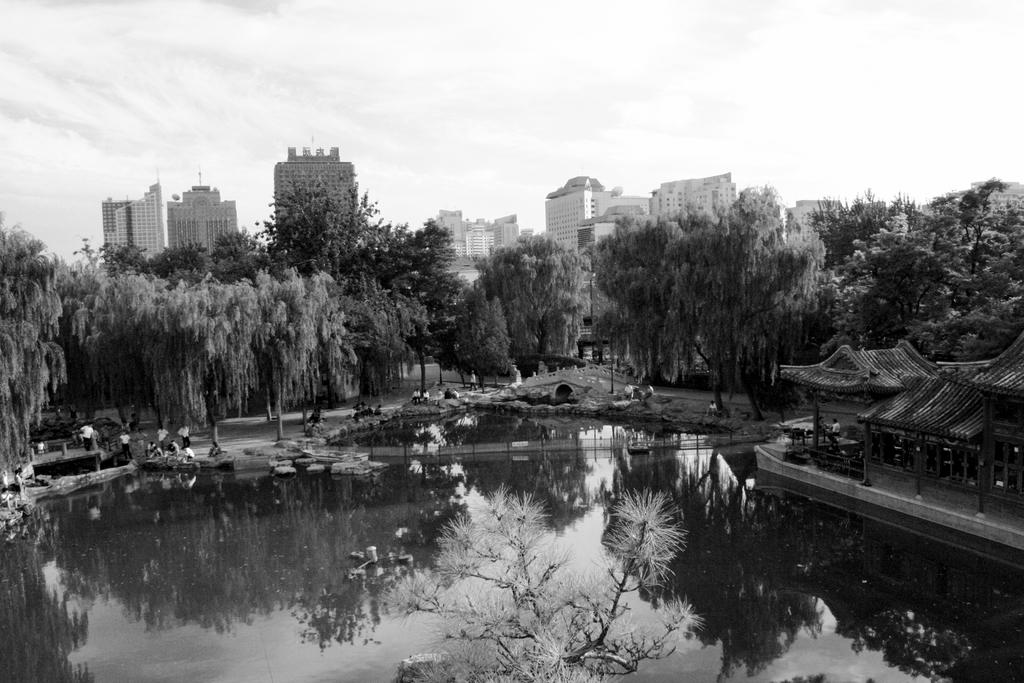What is the primary element in the image? There is water in the image. Can you describe the people in the image? There are people in the image. What can be seen in the background of the image? There are trees, buildings, and clouds in the background of the image. What is the color scheme of the image? The image is in black and white. What type of root can be seen growing in the water in the image? There is no root visible in the image; it only shows water, people, and the background elements. 